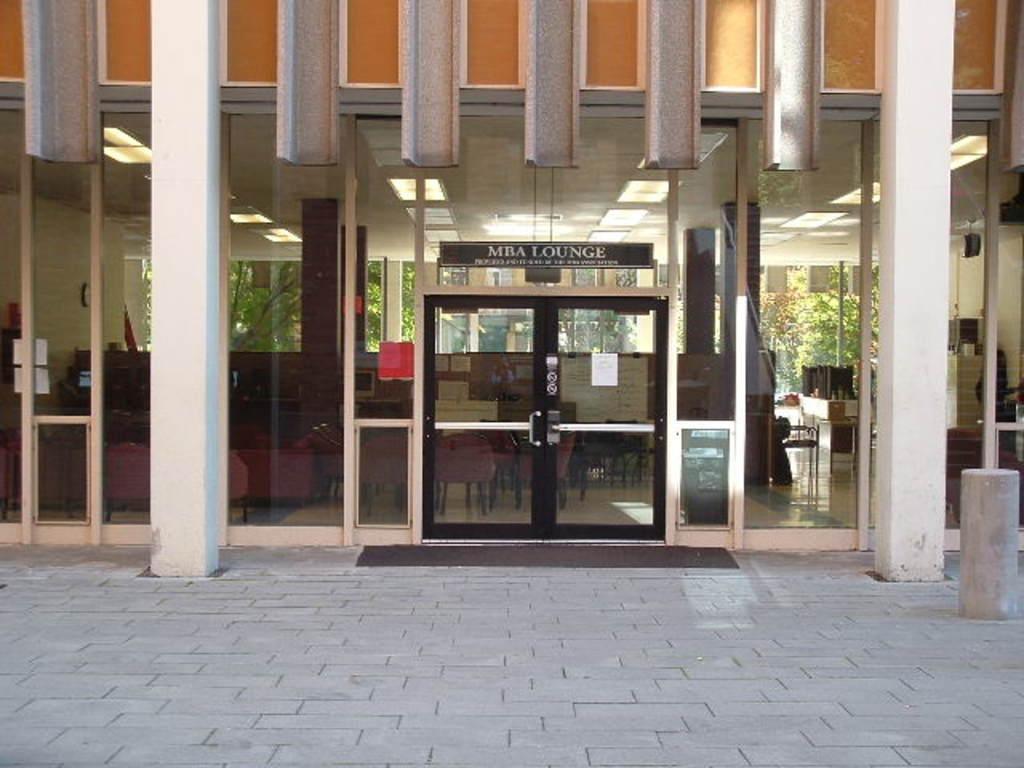Can you describe this image briefly? IN this image we can see a building, inside the buildings we can see some chairs and some other objects, there are some pillars, doors, trees and board with some text, on the building we can see some posters with text. 